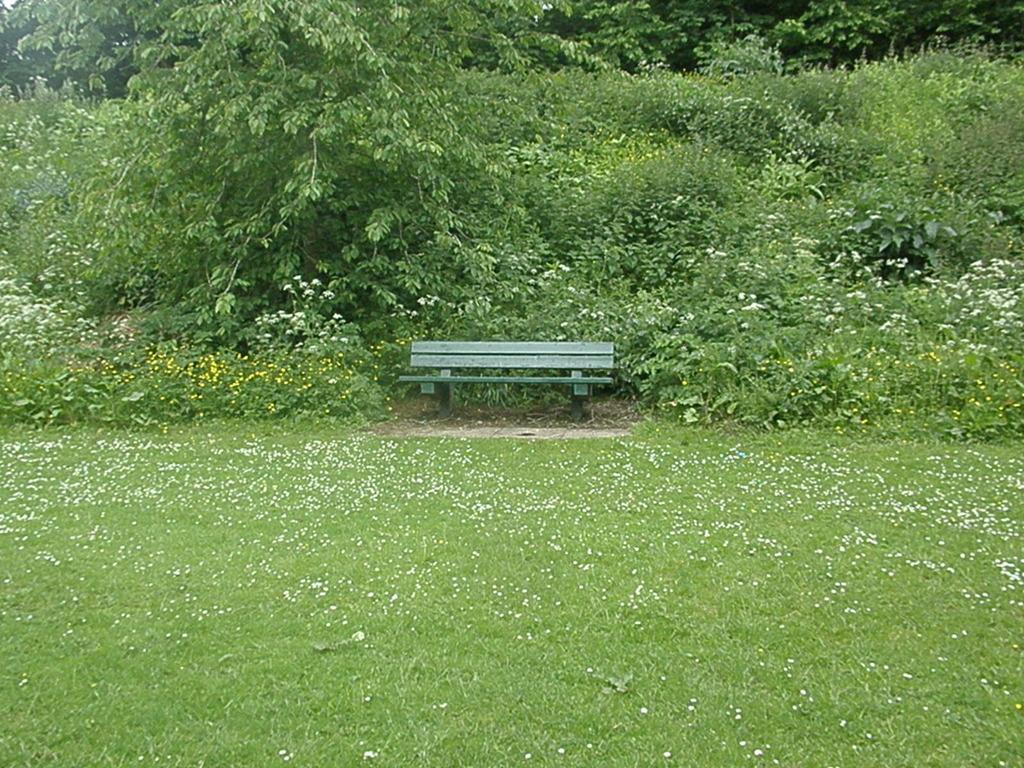What type of seating is visible in the image? There is a wooden bench in the image. What is on the ground in front of the bench? There is grass on the surface in front of the bench. What can be seen behind the bench? There are trees behind the bench. Where is the heart-shaped pocket located on the bench? There is no heart-shaped pocket present on the bench in the image. 